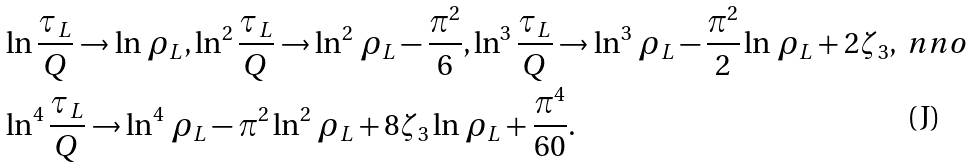Convert formula to latex. <formula><loc_0><loc_0><loc_500><loc_500>& \ln \frac { \tau _ { L } } { Q } \to \ln \, \rho _ { L } , \ln ^ { 2 } \frac { \tau _ { L } } { Q } \to \ln ^ { 2 } \, \rho _ { L } - \frac { \pi ^ { 2 } } { 6 } , \ln ^ { 3 } \frac { \tau _ { L } } { Q } \to \ln ^ { 3 } \, \rho _ { L } - \frac { \pi ^ { 2 } } { 2 } \ln \, \rho _ { L } + 2 \zeta _ { 3 } , \ n n o \\ & \ln ^ { 4 } \frac { \tau _ { L } } { Q } \to \ln ^ { 4 } \, \rho _ { L } - \pi ^ { 2 } \ln ^ { 2 } \, \rho _ { L } + 8 \zeta _ { 3 } \ln \, \rho _ { L } + \frac { \pi ^ { 4 } } { 6 0 } .</formula> 